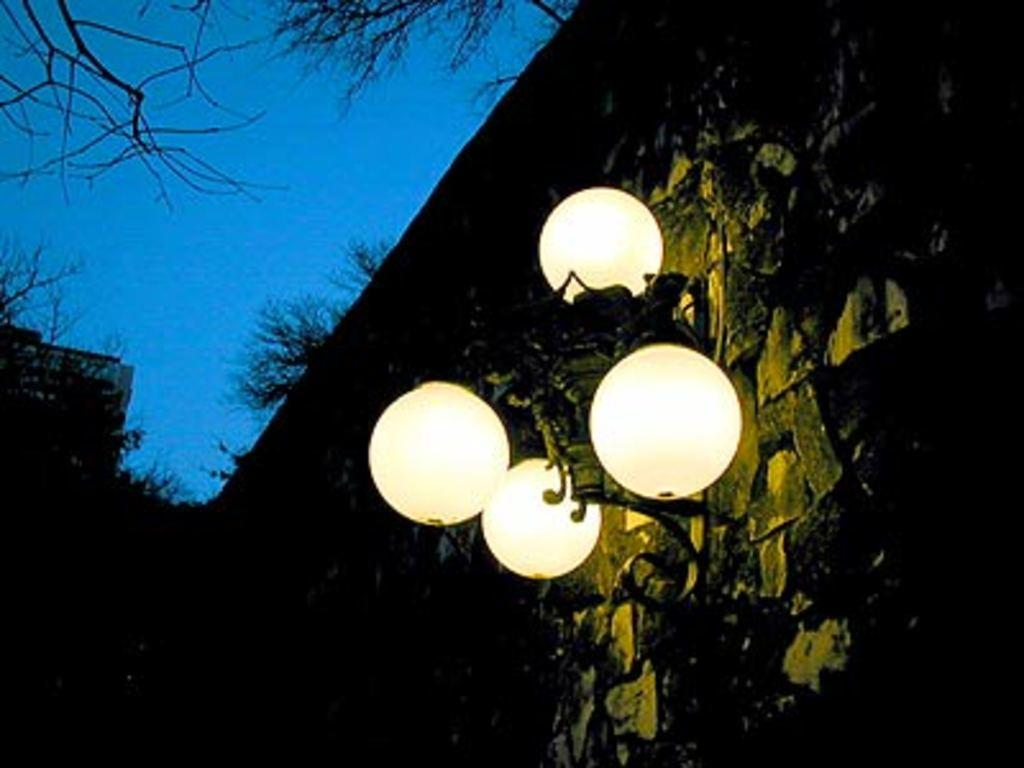What type of objects can be seen in the image? There are lamps in the image. What structure is present in the image? There is a building in the image. What type of vegetation is visible in the image? There are many trees in the image. What is visible in the background of the image? The sky is visible in the image. What type of coal is being used to fuel the lamps in the image? There is no coal present in the image, and the lamps are not fueled by coal. What type of cloth is draped over the trees in the image? There is no cloth draped over the trees in the image; the trees are not covered. 